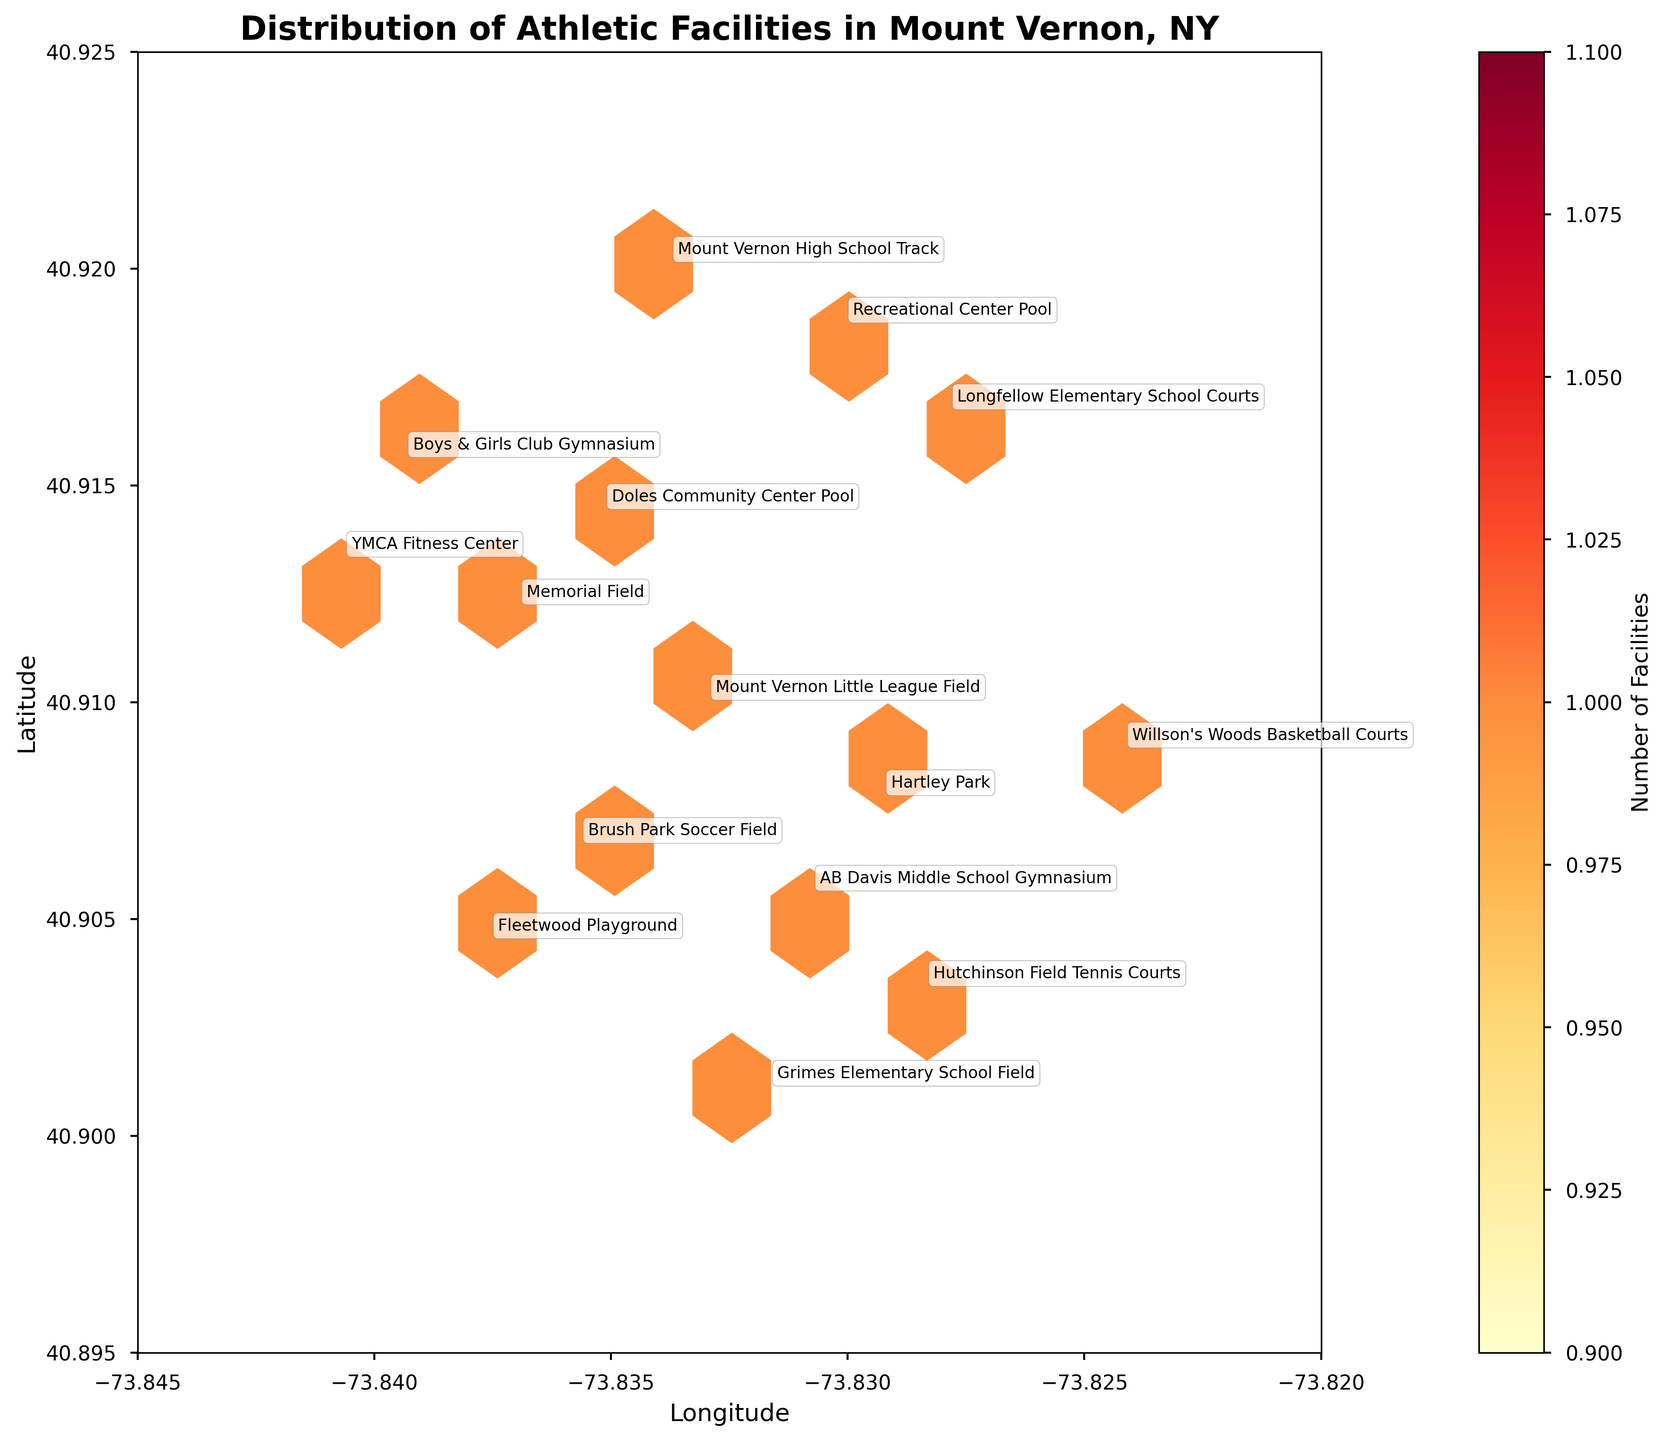What is the title of the hexbin plot? The title can be read directly from the top of the plot as it is clearly labeled.
Answer: Distribution of Athletic Facilities in Mount Vernon, NY How many athletic facilities are in the North Side neighborhood? By looking at the annotations on the hexbin plot, you can identify the facilities in the North Side neighborhood. They are Memorial Field, Recreational Center Pool, and Mount Vernon High School Track.
Answer: 3 Which neighborhood has the highest density of athletic facilities? By observing the hexbin plot's color intensity, the area around the North Side appears to have the highest density of hexagons, suggesting it has the highest concentration of athletic facilities.
Answer: North Side Which athletic facility is located at the easternmost longitude? The annotations provide the facility names and their positions on the plot. The facility closest to the eastern edge of the plot is Willson's Woods Basketball Courts.
Answer: Willson's Woods Basketball Courts What colors are used to represent the density of athletic facilities? The color of the hexagons represents density, shaded from light yellow to dark red. This can be observed from the color bar on the right side of the plot.
Answer: Yellow to red How many different types of athletic facilities are represented in the plot? By reading the annotations and categorizing the facility types, the different types are Stadium, Park, Pool, Court, Gym, Field, Track.
Answer: 7 Which facility is located furthest south? Looking at the latitude values and the annotations of the facilities on the plot, the facility closest to the southern edge is Grimes Elementary School Field.
Answer: Grimes Elementary School Field Compare the numbers of facilities between the East Side and Downtown neighborhoods. By checking the annotations for each neighborhood, East Side has Hartley Park and Willson's Woods Basketball Courts (2), while Downtown has Boys & Girls Club Gymnasium and YMCA Fitness Center (2).
Answer: Both have 2 facilities What is the average latitude of the facilities in the West Side neighborhood? Considering the latitudes of Brush Park Soccer Field (40.9067) and Fleetwood Playground (40.9045), the average is (40.9067 + 40.9045) / 2.
Answer: 40.9056 Which neighborhood has the lowest density of athletic facilities? By observing the hexbin plot and the color intensity, areas like the Southeast and Central have fewer hexagons and lower density.
Answer: Southeast / Central 